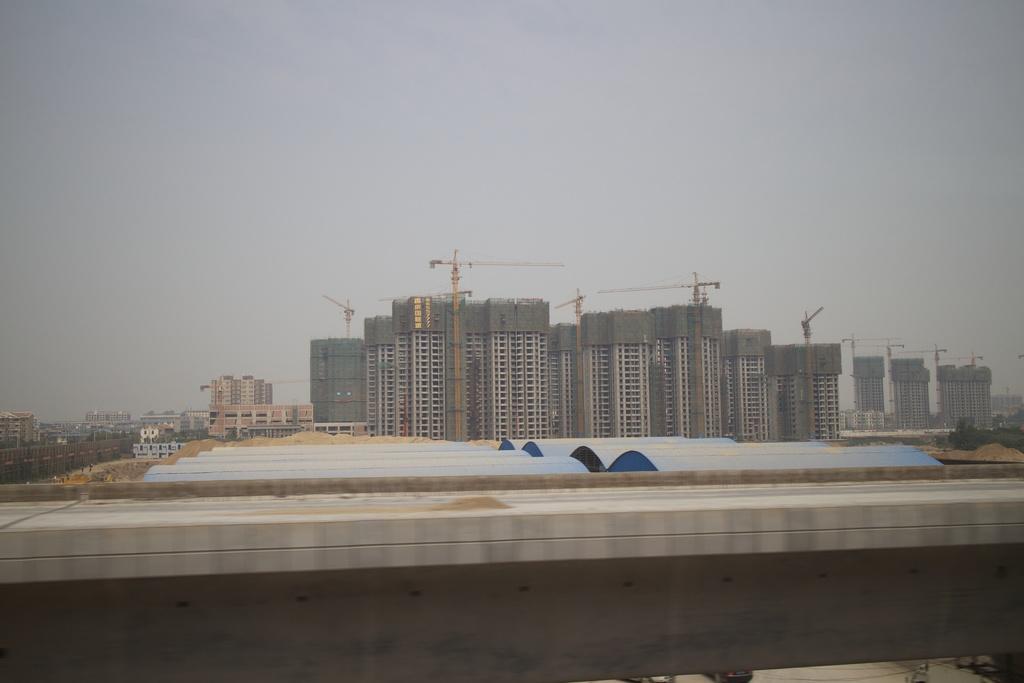Describe this image in one or two sentences. There are few buildings under construction and there are few other buildings in the left corner. 